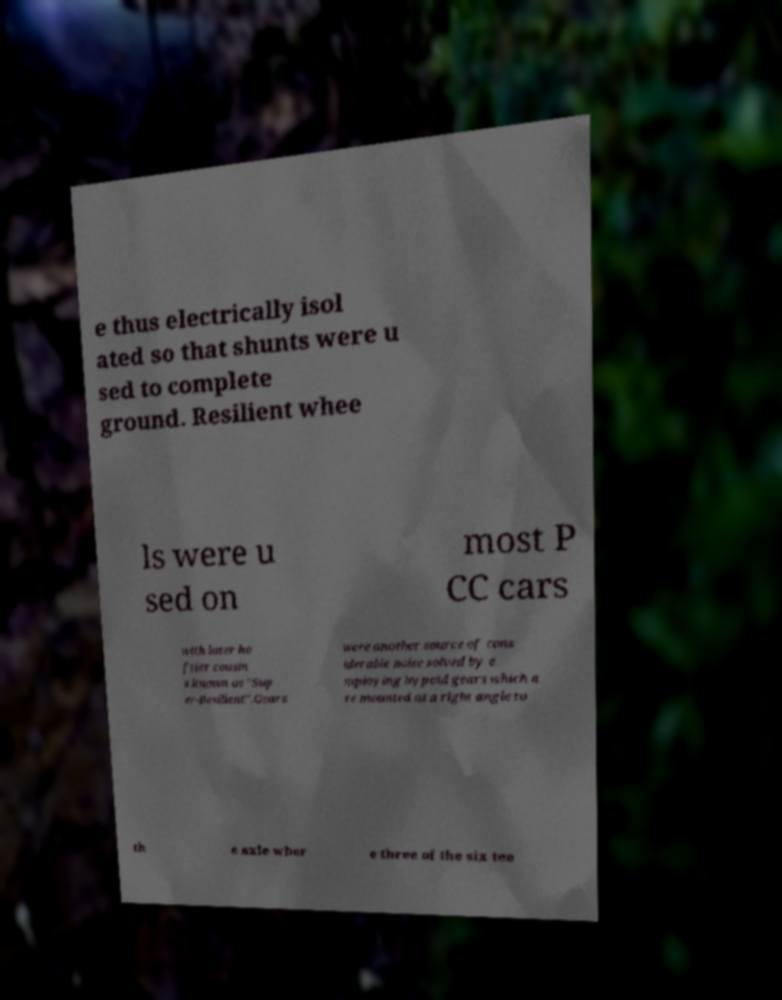Please identify and transcribe the text found in this image. e thus electrically isol ated so that shunts were u sed to complete ground. Resilient whee ls were u sed on most P CC cars with later he ftier cousin s known as "Sup er-Resilient".Gears were another source of cons iderable noise solved by e mploying hypoid gears which a re mounted at a right angle to th e axle wher e three of the six tee 